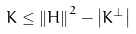Convert formula to latex. <formula><loc_0><loc_0><loc_500><loc_500>K \leq \left \| H \right \| ^ { 2 } - \left | K ^ { \perp } \right |</formula> 